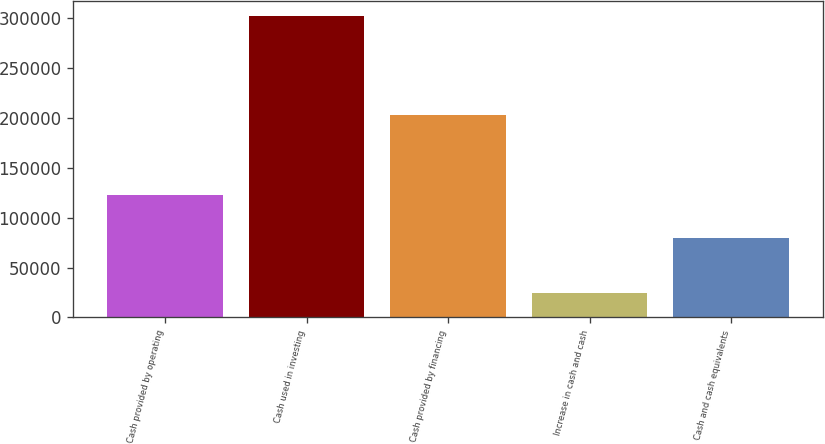<chart> <loc_0><loc_0><loc_500><loc_500><bar_chart><fcel>Cash provided by operating<fcel>Cash used in investing<fcel>Cash provided by financing<fcel>Increase in cash and cash<fcel>Cash and cash equivalents<nl><fcel>122934<fcel>301884<fcel>203074<fcel>24124<fcel>79676<nl></chart> 